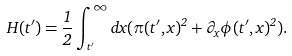<formula> <loc_0><loc_0><loc_500><loc_500>H ( t ^ { \prime } ) = \frac { 1 } { 2 } \int _ { t ^ { \prime } } ^ { \infty } d x ( \pi ( t ^ { \prime } , x ) ^ { 2 } + \partial _ { x } \phi ( t ^ { \prime } , x ) ^ { 2 } ) .</formula> 